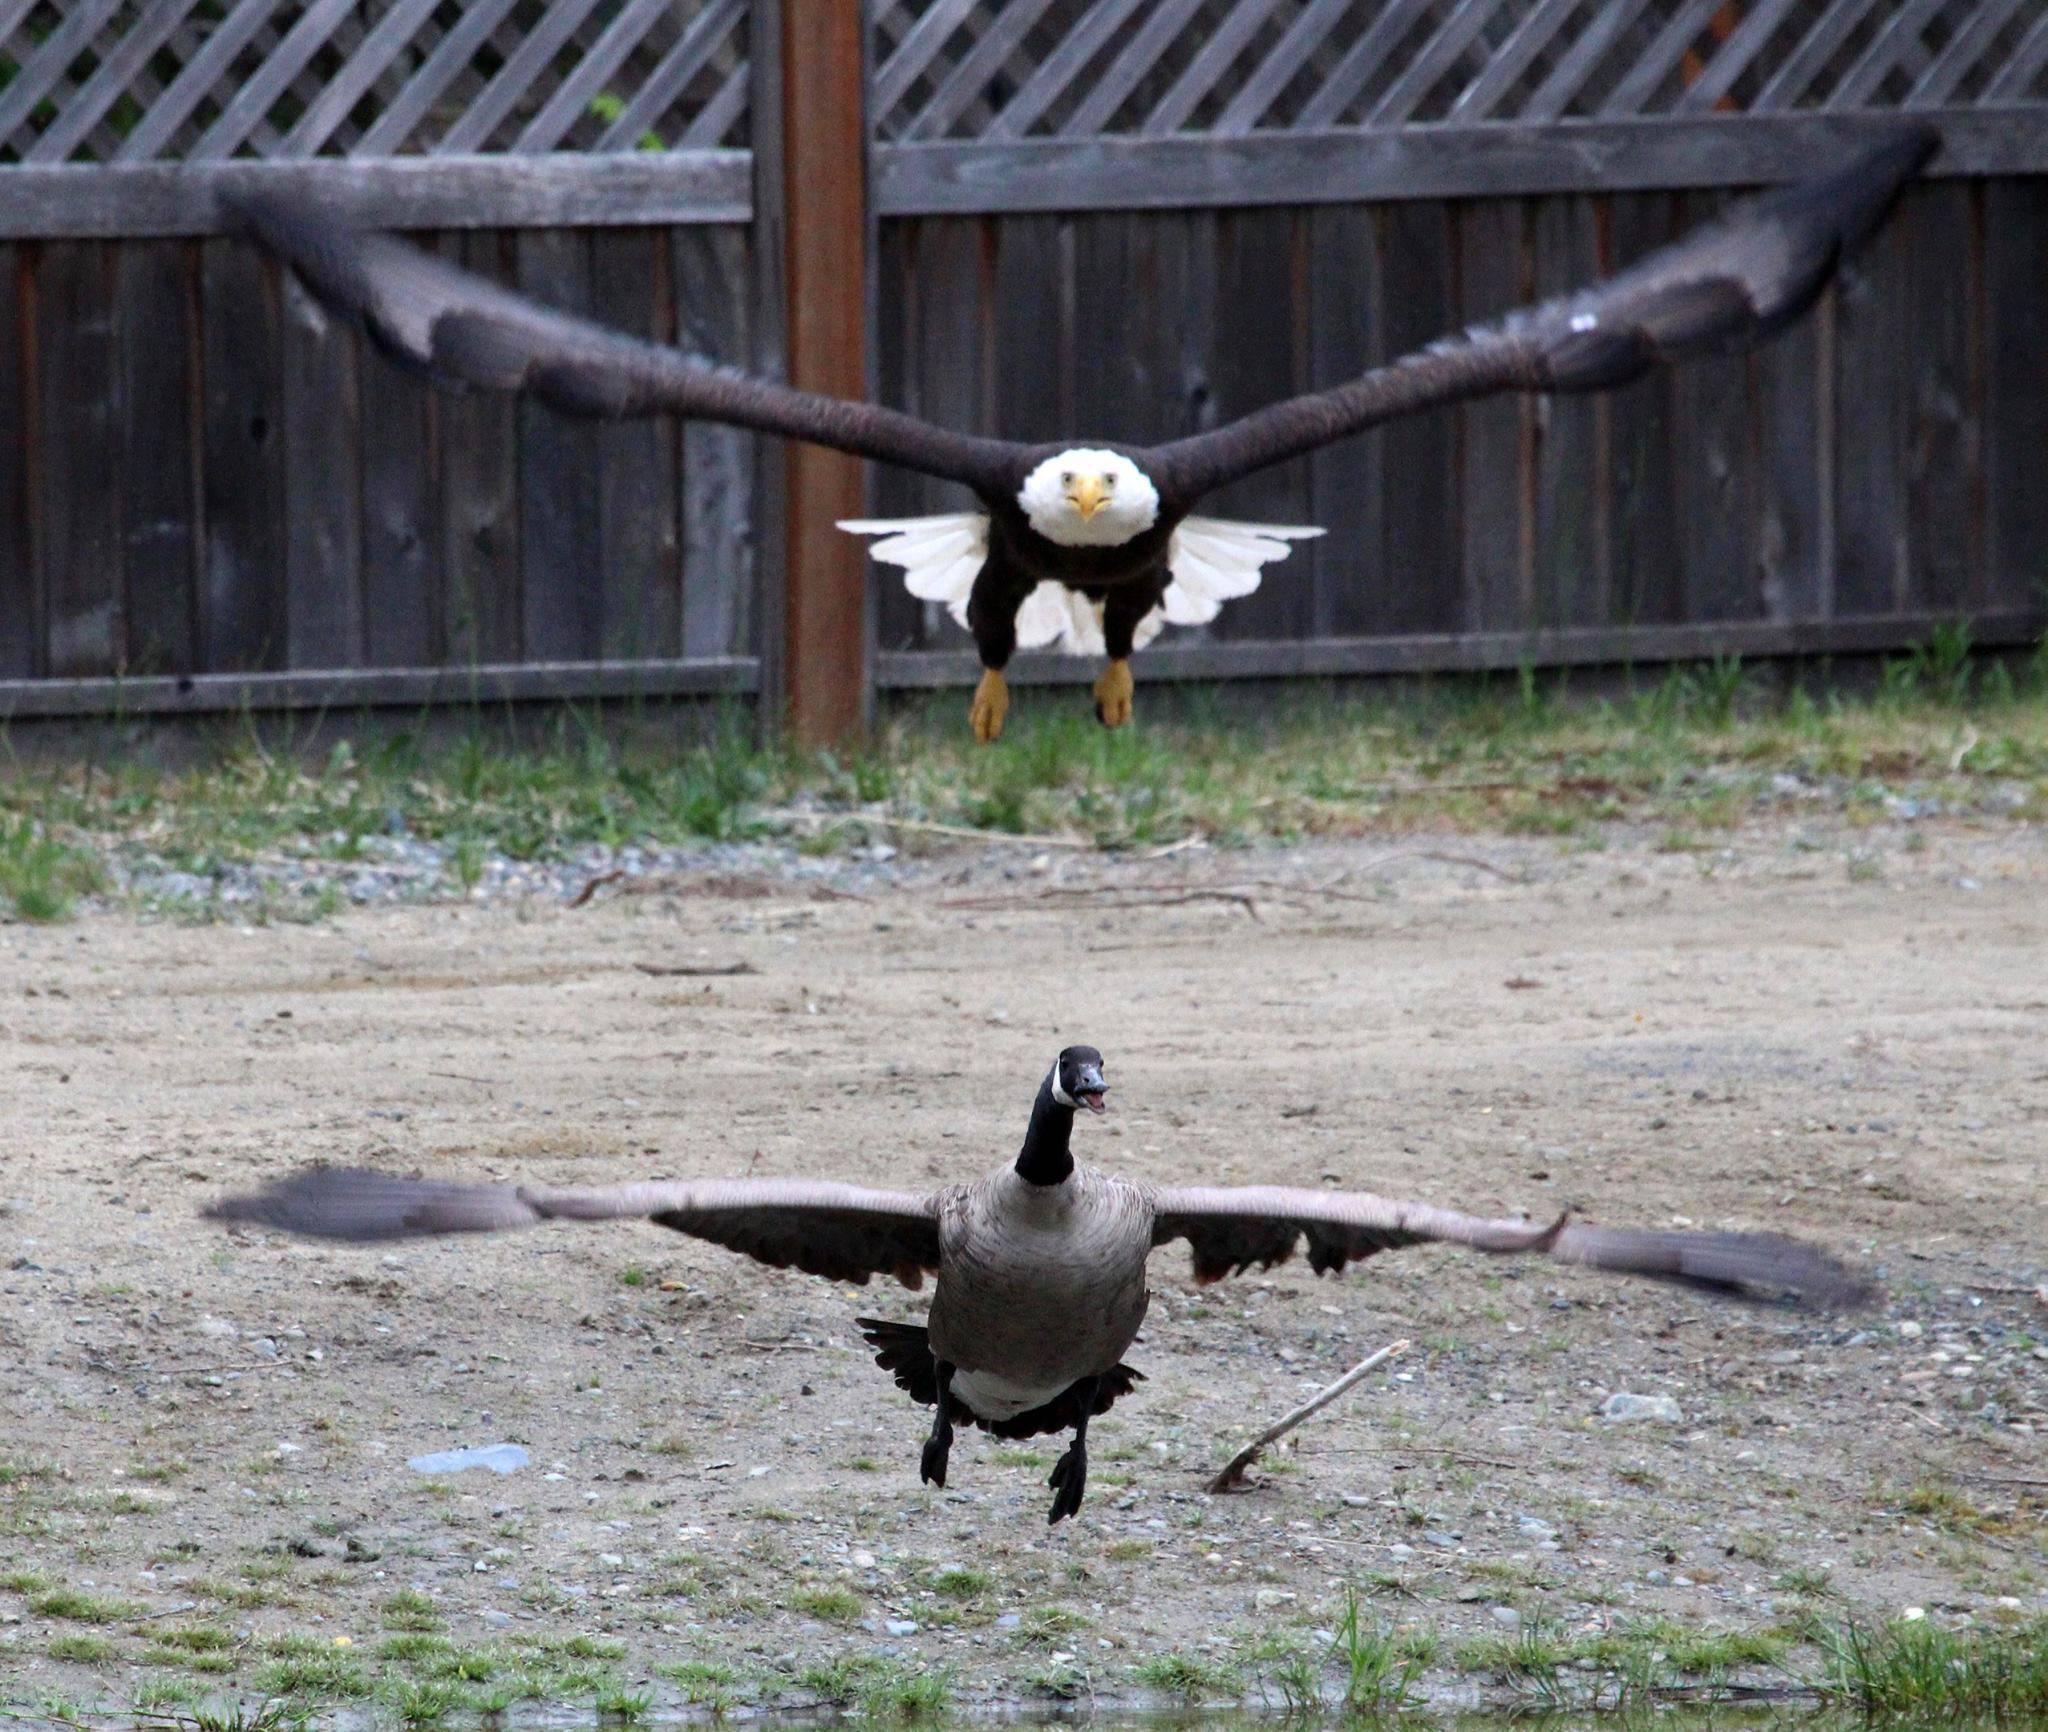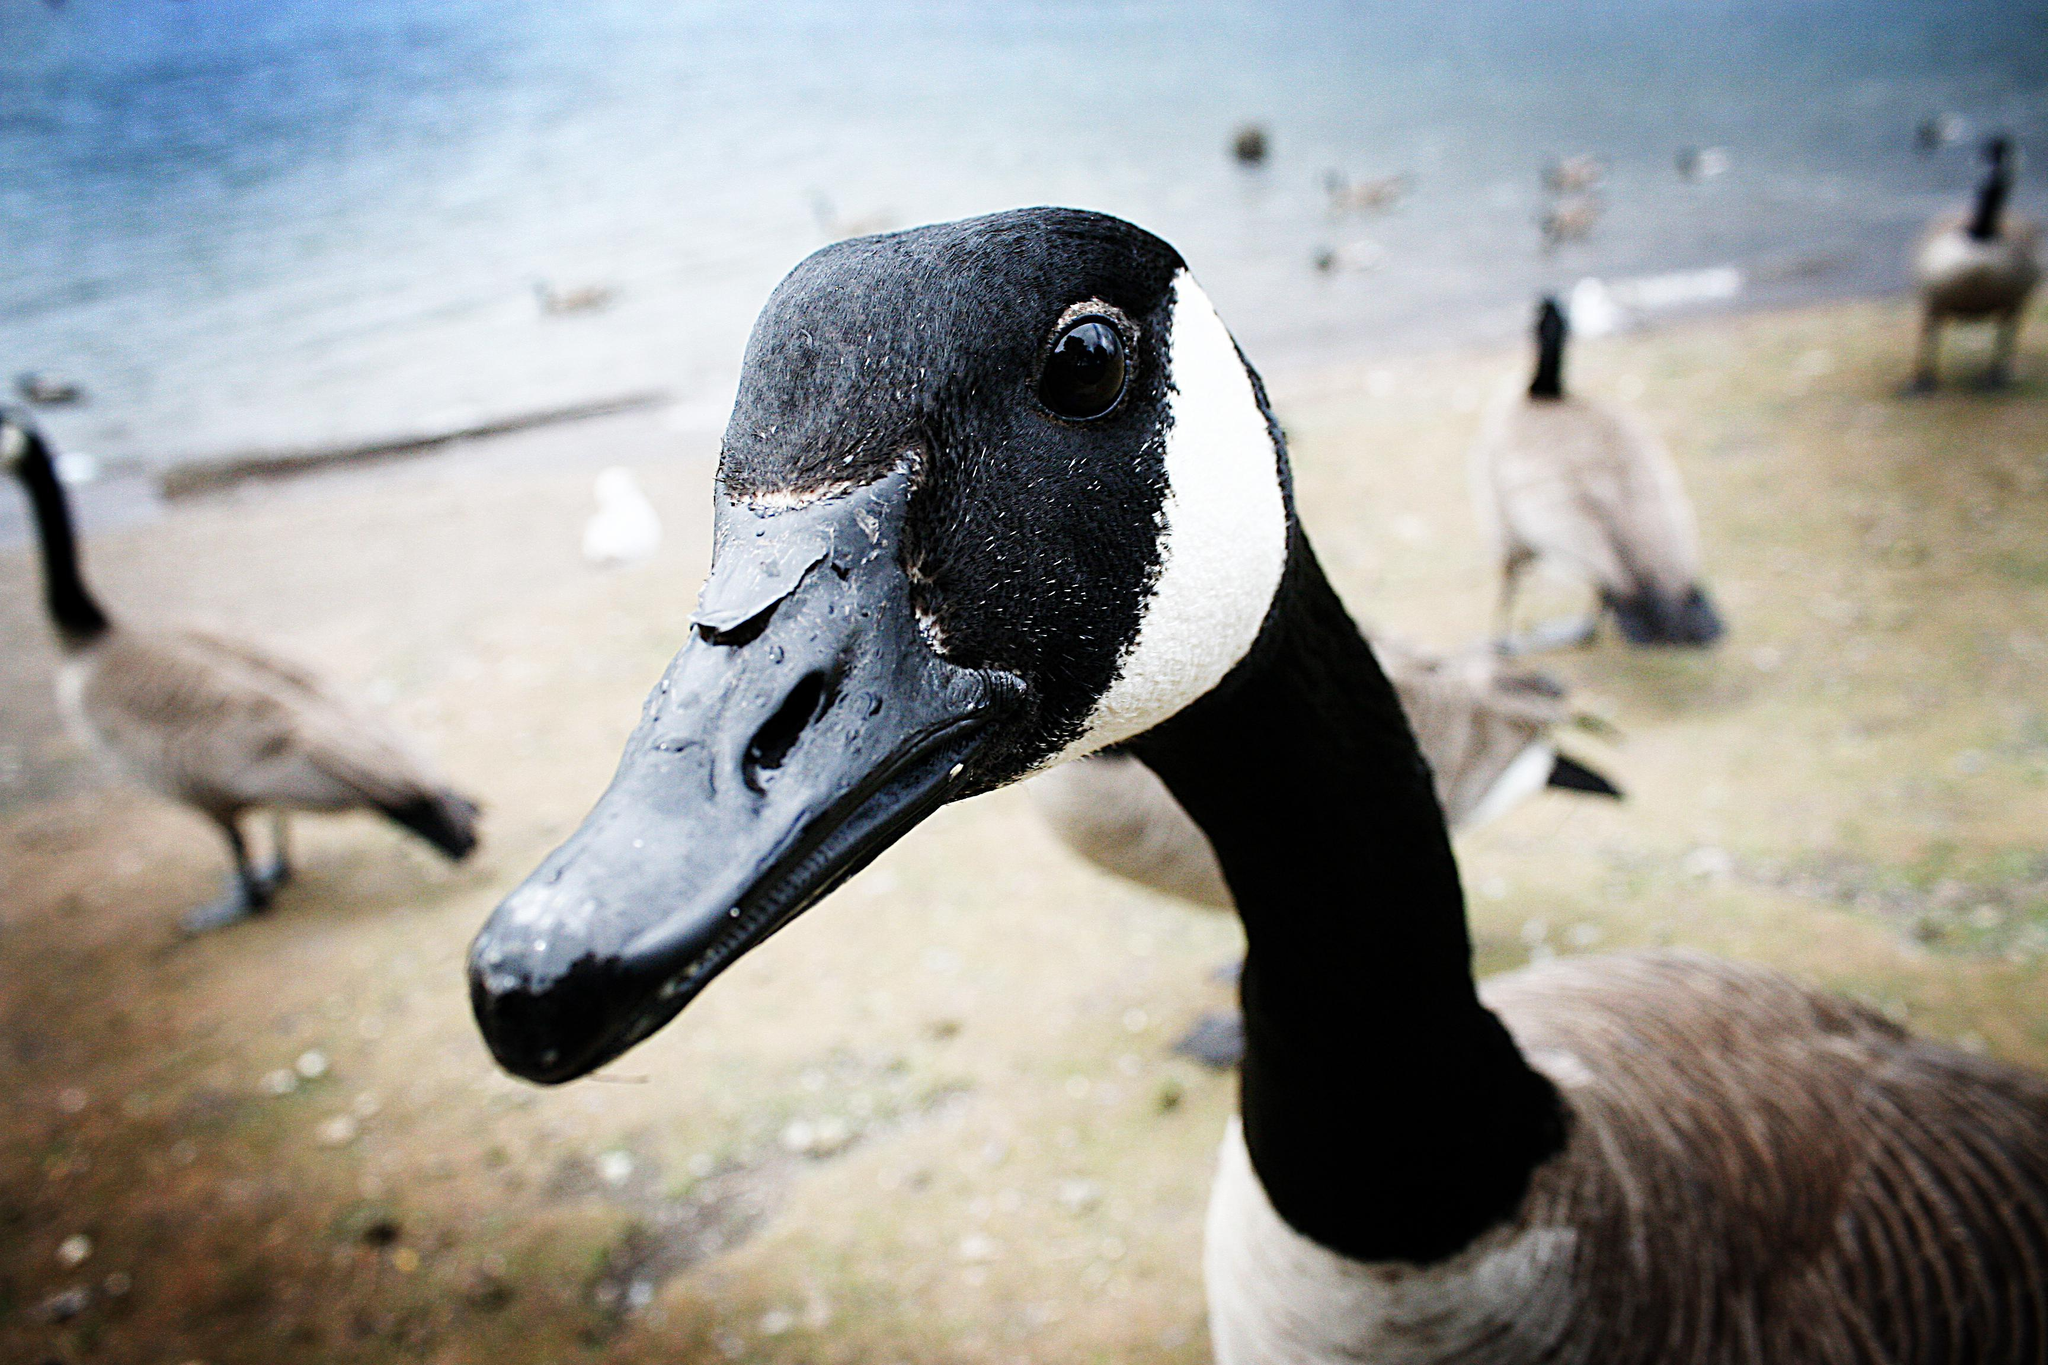The first image is the image on the left, the second image is the image on the right. Considering the images on both sides, is "In one image, two birds have wings outstretched with at least one of them in mid air." valid? Answer yes or no. Yes. The first image is the image on the left, the second image is the image on the right. Analyze the images presented: Is the assertion "There is one eagle" valid? Answer yes or no. Yes. 